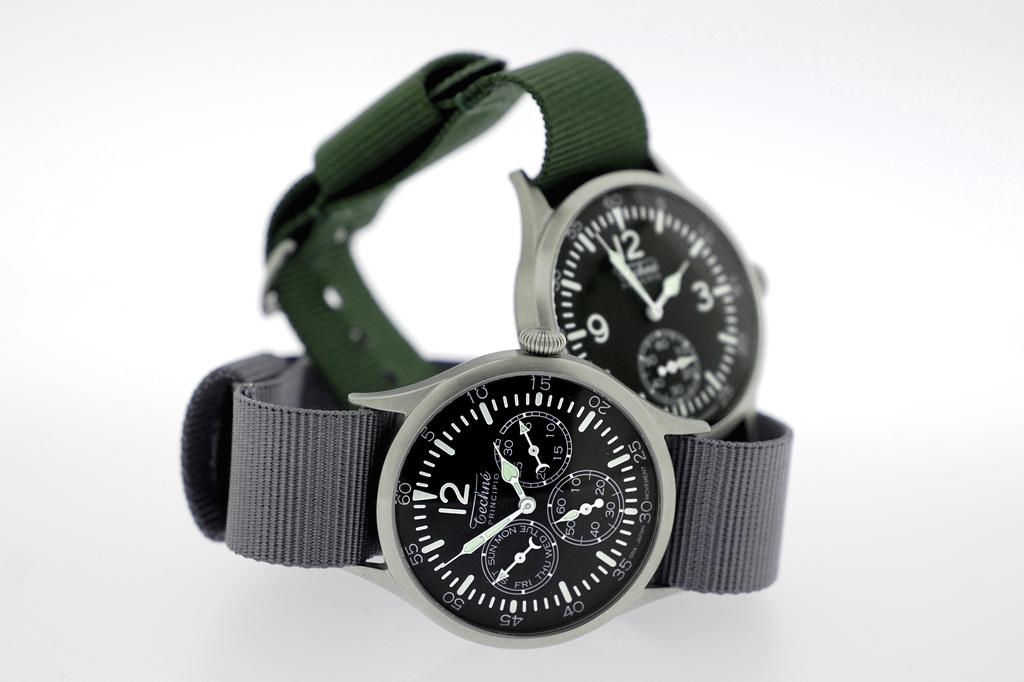Which numbers are visible on the watch with the green strap?
Keep it short and to the point. 9 12 3. What number is the only time number shown on the grey watch?
Your answer should be compact. 12. 